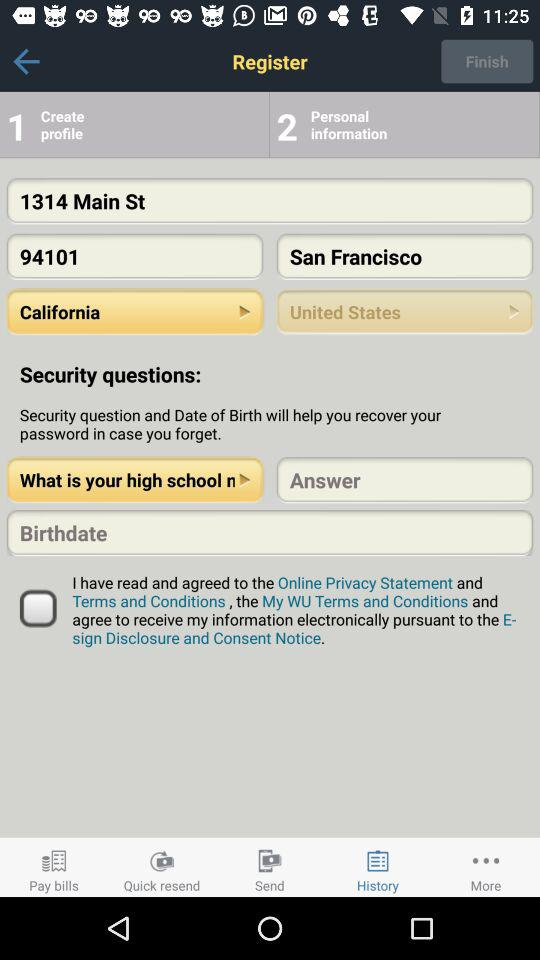What is the status of the option that includes acceptance to the “Terms and Conditions”? The status of the option that includes acceptance to the "Terms and Conditions" is "off". 